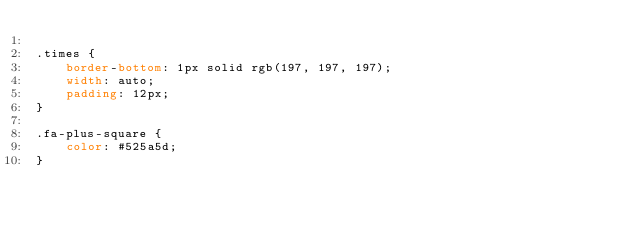Convert code to text. <code><loc_0><loc_0><loc_500><loc_500><_CSS_>
.times {
    border-bottom: 1px solid rgb(197, 197, 197);
    width: auto;
    padding: 12px;
}

.fa-plus-square {
    color: #525a5d;
}
</code> 